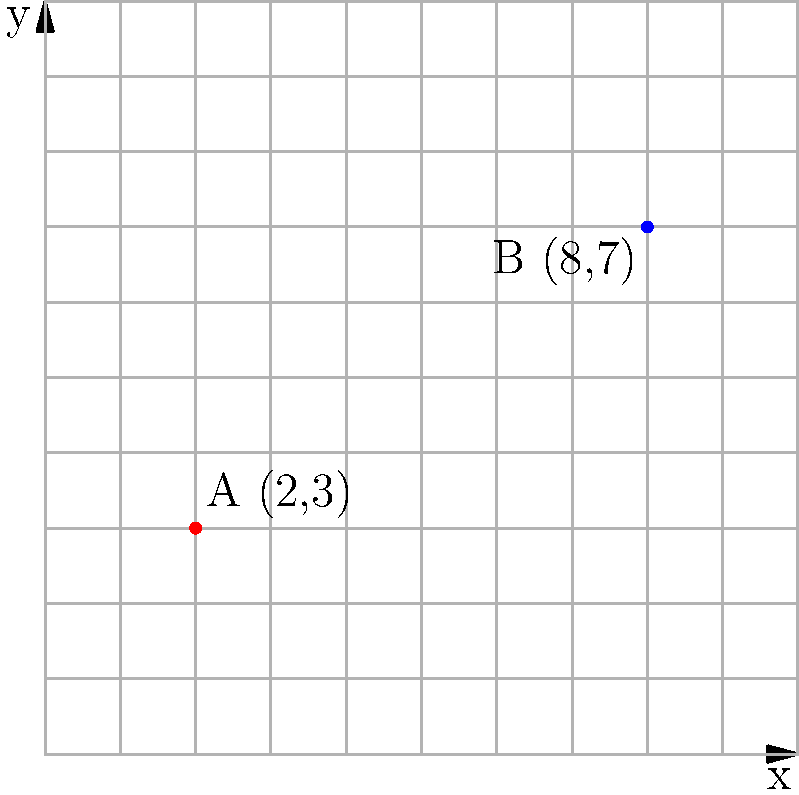As a wannabe model trying to improve your career prospects, you're considering two modeling agencies in your city. Agency A is located at coordinates (2,3) and Agency B is at (8,7) on the city grid. Each unit on the grid represents 1 block. What is the shortest distance between these two agencies? Round your answer to the nearest tenth of a block. Let's approach this step-by-step:

1) We can use the distance formula to calculate the shortest distance between two points on a coordinate plane. The formula is:

   $$d = \sqrt{(x_2-x_1)^2 + (y_2-y_1)^2}$$

   Where $(x_1,y_1)$ is the coordinate of the first point and $(x_2,y_2)$ is the coordinate of the second point.

2) In this case:
   - Agency A is at (2,3), so $x_1 = 2$ and $y_1 = 3$
   - Agency B is at (8,7), so $x_2 = 8$ and $y_2 = 7$

3) Let's substitute these values into the formula:

   $$d = \sqrt{(8-2)^2 + (7-3)^2}$$

4) Simplify inside the parentheses:

   $$d = \sqrt{6^2 + 4^2}$$

5) Calculate the squares:

   $$d = \sqrt{36 + 16}$$

6) Add inside the square root:

   $$d = \sqrt{52}$$

7) Simplify the square root:

   $$d = 7.21110...$$

8) Rounding to the nearest tenth:

   $$d \approx 7.2$$

Therefore, the shortest distance between the two agencies is approximately 7.2 blocks.
Answer: 7.2 blocks 